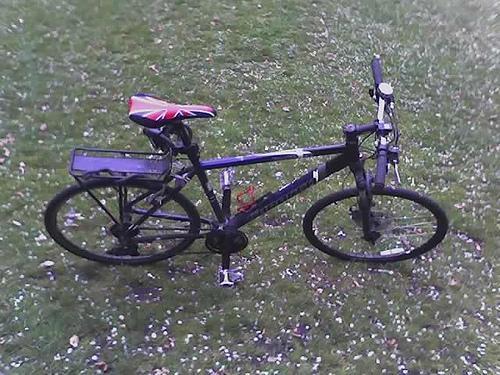How many water racks on the bike?
Give a very brief answer. 1. How many wheels?
Give a very brief answer. 2. 